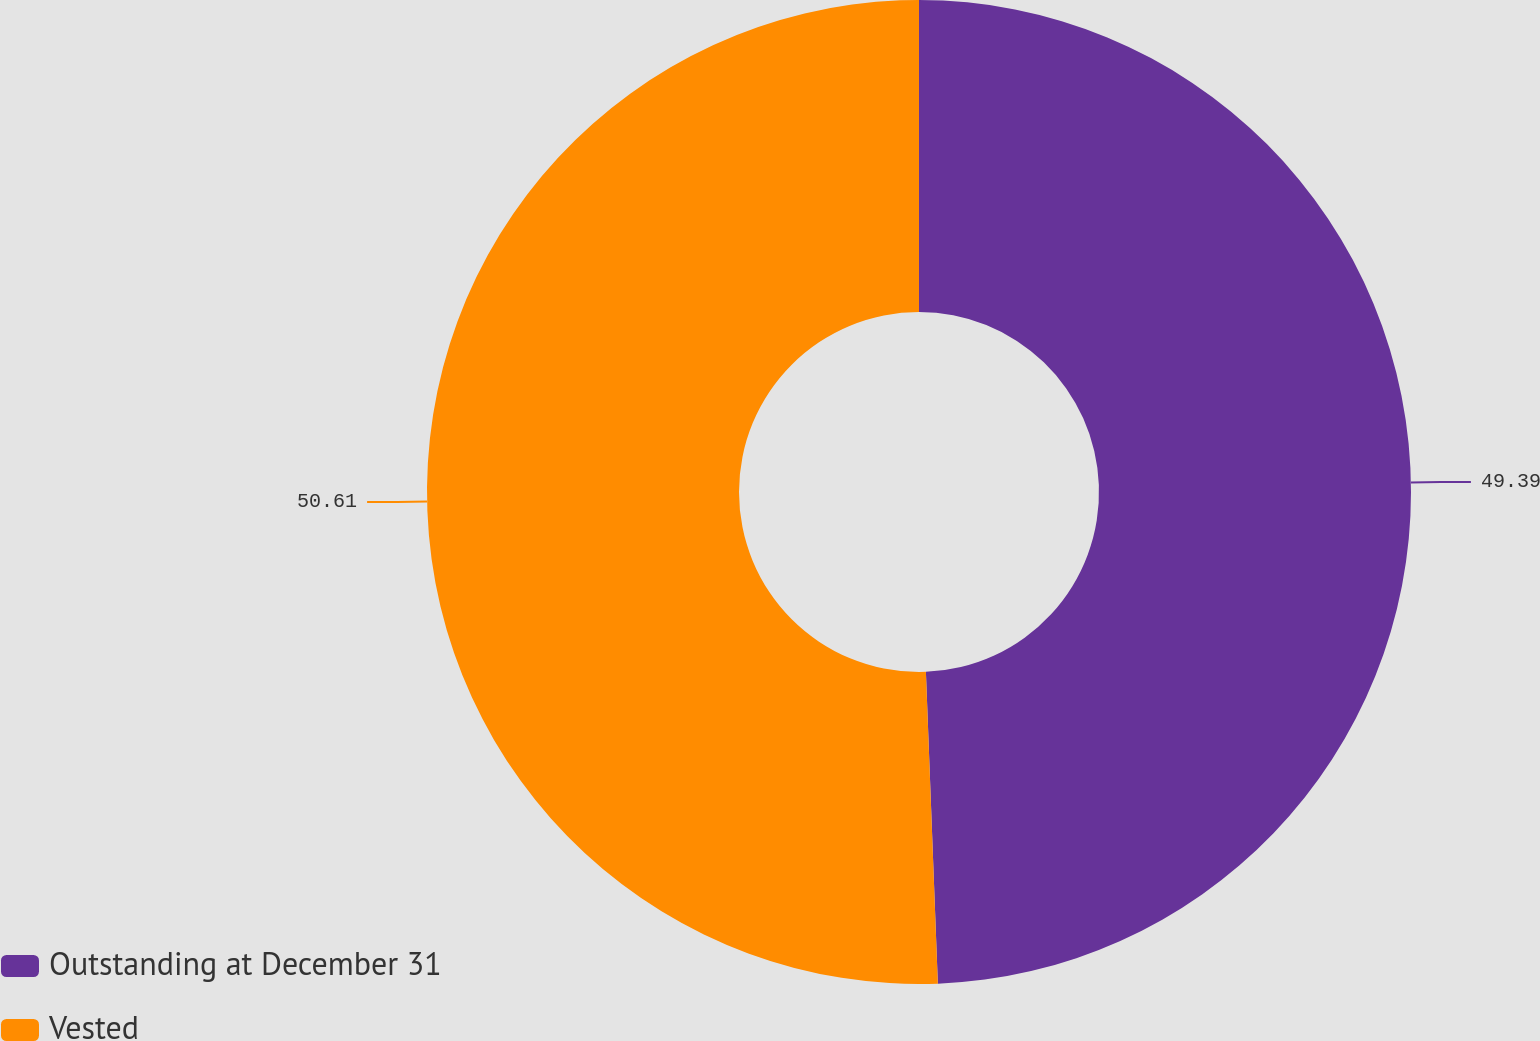Convert chart. <chart><loc_0><loc_0><loc_500><loc_500><pie_chart><fcel>Outstanding at December 31<fcel>Vested<nl><fcel>49.39%<fcel>50.61%<nl></chart> 